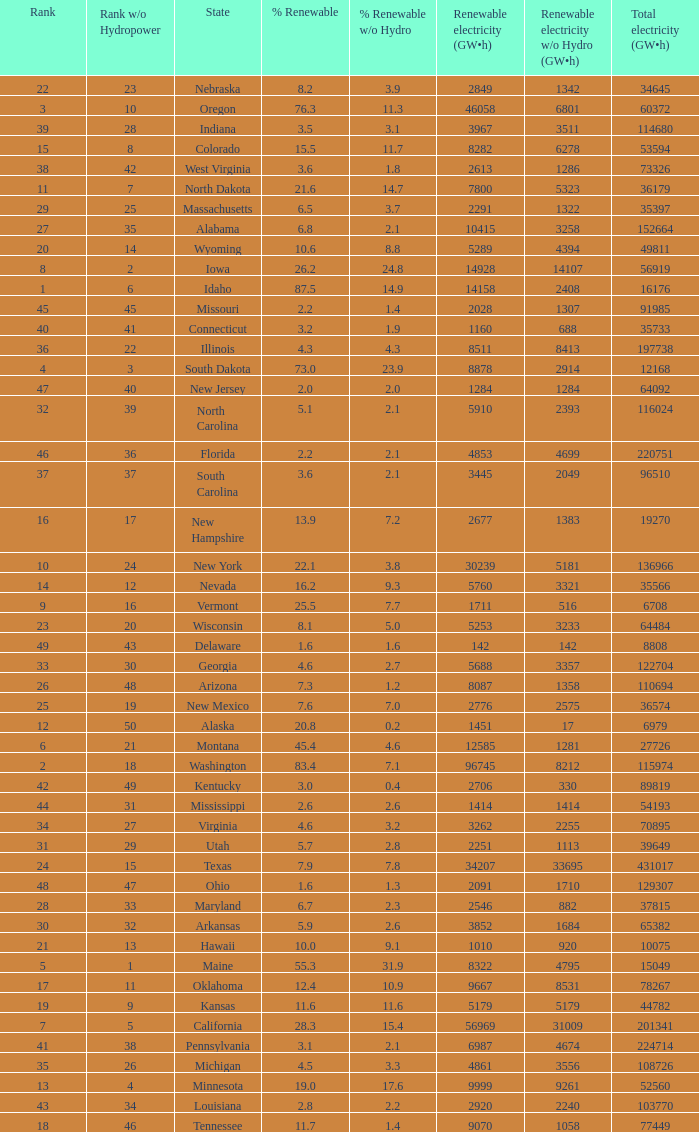Which state has 5179 (gw×h) of renewable energy without hydrogen power?wha Kansas. Can you give me this table as a dict? {'header': ['Rank', 'Rank w/o Hydropower', 'State', '% Renewable', '% Renewable w/o Hydro', 'Renewable electricity (GW•h)', 'Renewable electricity w/o Hydro (GW•h)', 'Total electricity (GW•h)'], 'rows': [['22', '23', 'Nebraska', '8.2', '3.9', '2849', '1342', '34645'], ['3', '10', 'Oregon', '76.3', '11.3', '46058', '6801', '60372'], ['39', '28', 'Indiana', '3.5', '3.1', '3967', '3511', '114680'], ['15', '8', 'Colorado', '15.5', '11.7', '8282', '6278', '53594'], ['38', '42', 'West Virginia', '3.6', '1.8', '2613', '1286', '73326'], ['11', '7', 'North Dakota', '21.6', '14.7', '7800', '5323', '36179'], ['29', '25', 'Massachusetts', '6.5', '3.7', '2291', '1322', '35397'], ['27', '35', 'Alabama', '6.8', '2.1', '10415', '3258', '152664'], ['20', '14', 'Wyoming', '10.6', '8.8', '5289', '4394', '49811'], ['8', '2', 'Iowa', '26.2', '24.8', '14928', '14107', '56919'], ['1', '6', 'Idaho', '87.5', '14.9', '14158', '2408', '16176'], ['45', '45', 'Missouri', '2.2', '1.4', '2028', '1307', '91985'], ['40', '41', 'Connecticut', '3.2', '1.9', '1160', '688', '35733'], ['36', '22', 'Illinois', '4.3', '4.3', '8511', '8413', '197738'], ['4', '3', 'South Dakota', '73.0', '23.9', '8878', '2914', '12168'], ['47', '40', 'New Jersey', '2.0', '2.0', '1284', '1284', '64092'], ['32', '39', 'North Carolina', '5.1', '2.1', '5910', '2393', '116024'], ['46', '36', 'Florida', '2.2', '2.1', '4853', '4699', '220751'], ['37', '37', 'South Carolina', '3.6', '2.1', '3445', '2049', '96510'], ['16', '17', 'New Hampshire', '13.9', '7.2', '2677', '1383', '19270'], ['10', '24', 'New York', '22.1', '3.8', '30239', '5181', '136966'], ['14', '12', 'Nevada', '16.2', '9.3', '5760', '3321', '35566'], ['9', '16', 'Vermont', '25.5', '7.7', '1711', '516', '6708'], ['23', '20', 'Wisconsin', '8.1', '5.0', '5253', '3233', '64484'], ['49', '43', 'Delaware', '1.6', '1.6', '142', '142', '8808'], ['33', '30', 'Georgia', '4.6', '2.7', '5688', '3357', '122704'], ['26', '48', 'Arizona', '7.3', '1.2', '8087', '1358', '110694'], ['25', '19', 'New Mexico', '7.6', '7.0', '2776', '2575', '36574'], ['12', '50', 'Alaska', '20.8', '0.2', '1451', '17', '6979'], ['6', '21', 'Montana', '45.4', '4.6', '12585', '1281', '27726'], ['2', '18', 'Washington', '83.4', '7.1', '96745', '8212', '115974'], ['42', '49', 'Kentucky', '3.0', '0.4', '2706', '330', '89819'], ['44', '31', 'Mississippi', '2.6', '2.6', '1414', '1414', '54193'], ['34', '27', 'Virginia', '4.6', '3.2', '3262', '2255', '70895'], ['31', '29', 'Utah', '5.7', '2.8', '2251', '1113', '39649'], ['24', '15', 'Texas', '7.9', '7.8', '34207', '33695', '431017'], ['48', '47', 'Ohio', '1.6', '1.3', '2091', '1710', '129307'], ['28', '33', 'Maryland', '6.7', '2.3', '2546', '882', '37815'], ['30', '32', 'Arkansas', '5.9', '2.6', '3852', '1684', '65382'], ['21', '13', 'Hawaii', '10.0', '9.1', '1010', '920', '10075'], ['5', '1', 'Maine', '55.3', '31.9', '8322', '4795', '15049'], ['17', '11', 'Oklahoma', '12.4', '10.9', '9667', '8531', '78267'], ['19', '9', 'Kansas', '11.6', '11.6', '5179', '5179', '44782'], ['7', '5', 'California', '28.3', '15.4', '56969', '31009', '201341'], ['41', '38', 'Pennsylvania', '3.1', '2.1', '6987', '4674', '224714'], ['35', '26', 'Michigan', '4.5', '3.3', '4861', '3556', '108726'], ['13', '4', 'Minnesota', '19.0', '17.6', '9999', '9261', '52560'], ['43', '34', 'Louisiana', '2.8', '2.2', '2920', '2240', '103770'], ['18', '46', 'Tennessee', '11.7', '1.4', '9070', '1058', '77449']]} 